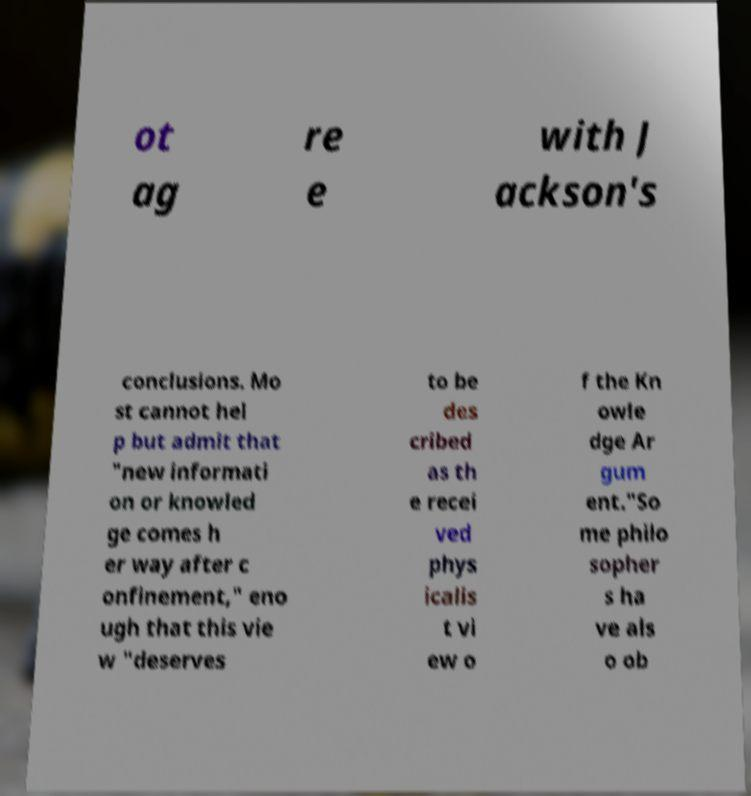For documentation purposes, I need the text within this image transcribed. Could you provide that? ot ag re e with J ackson's conclusions. Mo st cannot hel p but admit that "new informati on or knowled ge comes h er way after c onfinement," eno ugh that this vie w "deserves to be des cribed as th e recei ved phys icalis t vi ew o f the Kn owle dge Ar gum ent."So me philo sopher s ha ve als o ob 